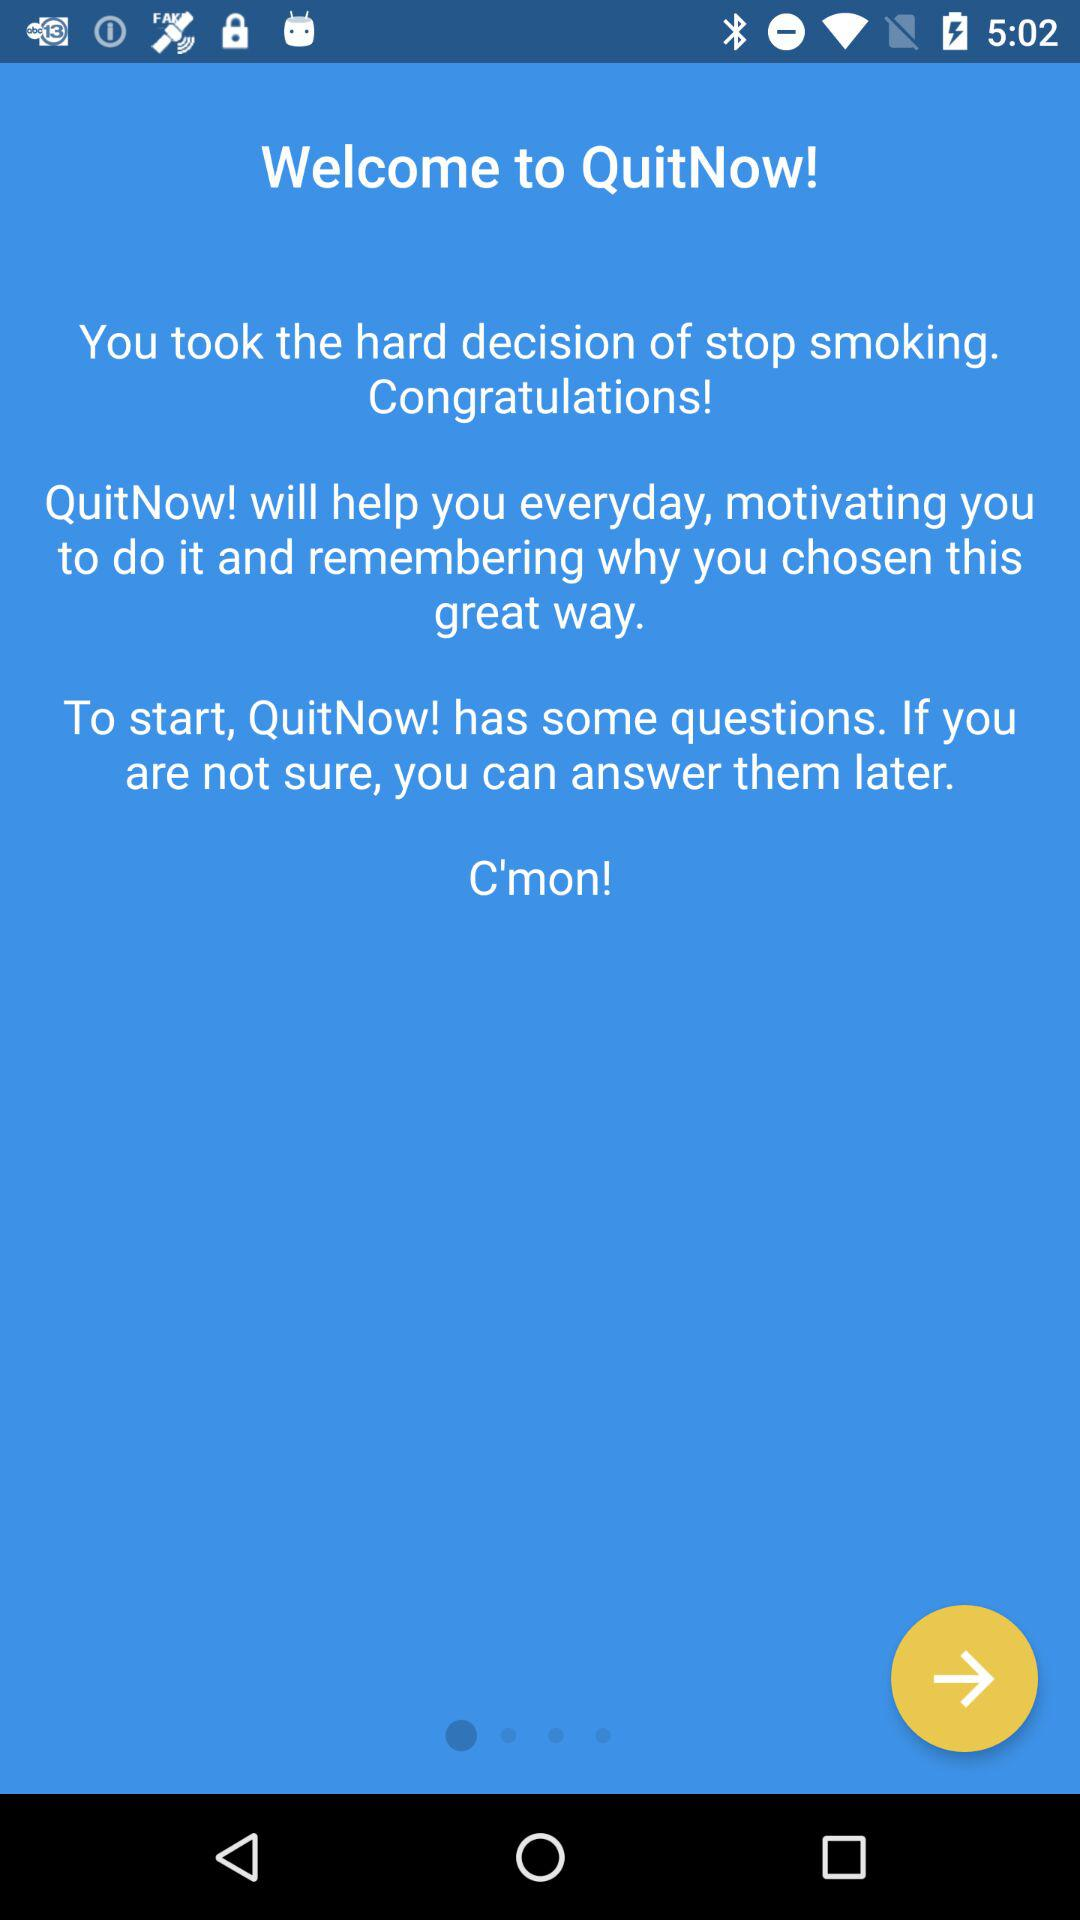How does "QuitNow!" help? "QuitNow!" helps you every day, motivating you to do it and remembering you why you chose this great way. 